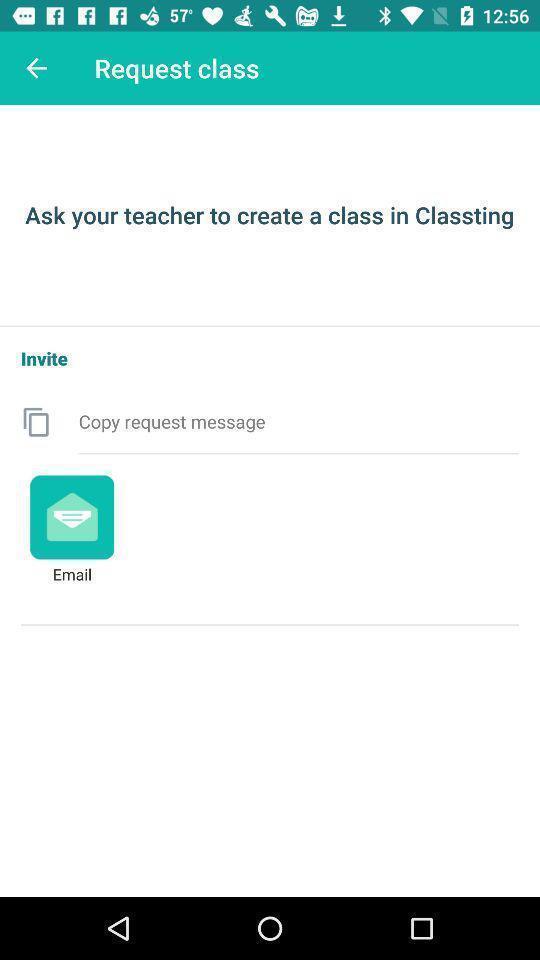Provide a detailed account of this screenshot. Page requesting to create a class on an app. 